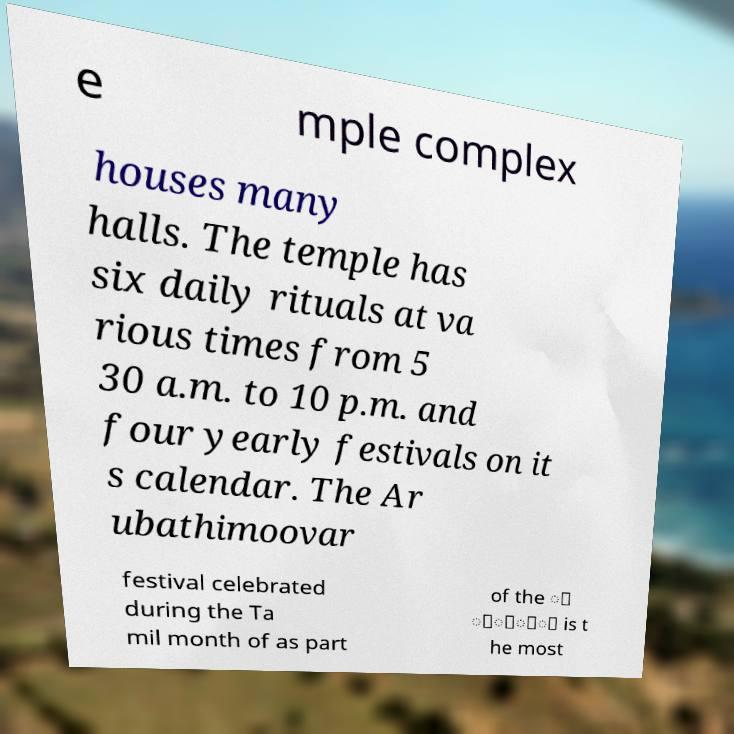Can you accurately transcribe the text from the provided image for me? e mple complex houses many halls. The temple has six daily rituals at va rious times from 5 30 a.m. to 10 p.m. and four yearly festivals on it s calendar. The Ar ubathimoovar festival celebrated during the Ta mil month of as part of the ் ்ோ்் is t he most 